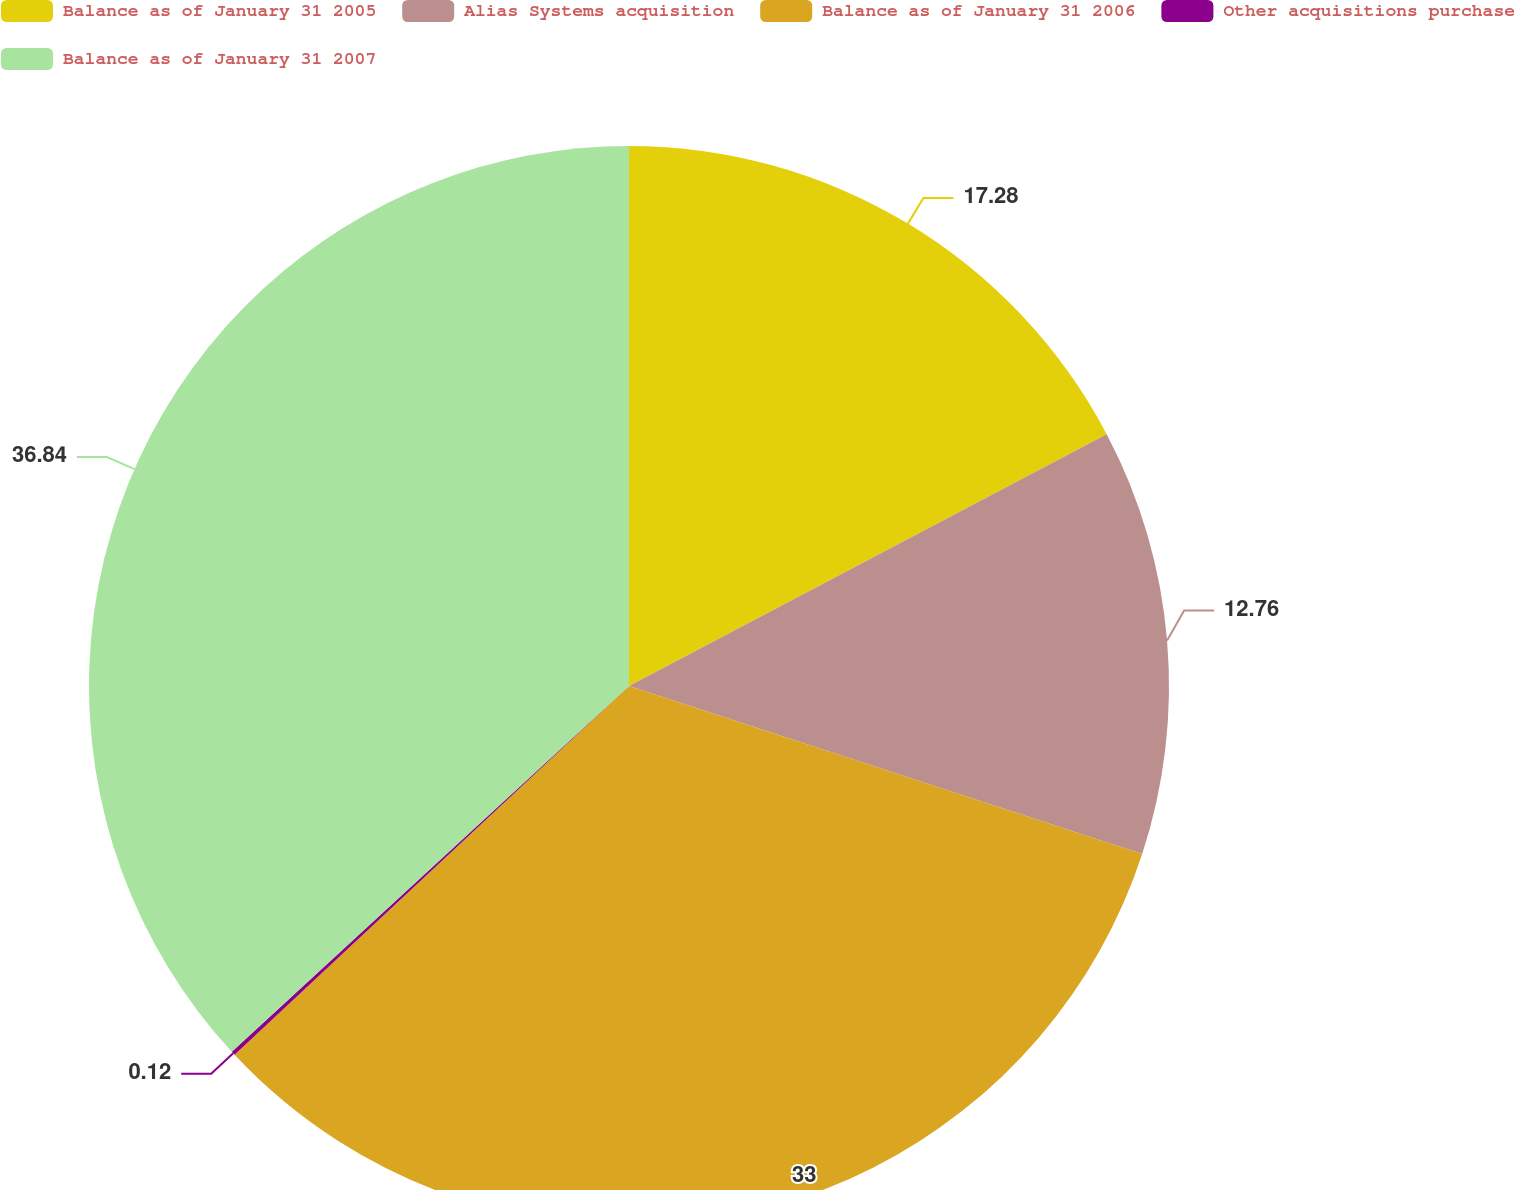Convert chart. <chart><loc_0><loc_0><loc_500><loc_500><pie_chart><fcel>Balance as of January 31 2005<fcel>Alias Systems acquisition<fcel>Balance as of January 31 2006<fcel>Other acquisitions purchase<fcel>Balance as of January 31 2007<nl><fcel>17.28%<fcel>12.76%<fcel>33.0%<fcel>0.12%<fcel>36.85%<nl></chart> 